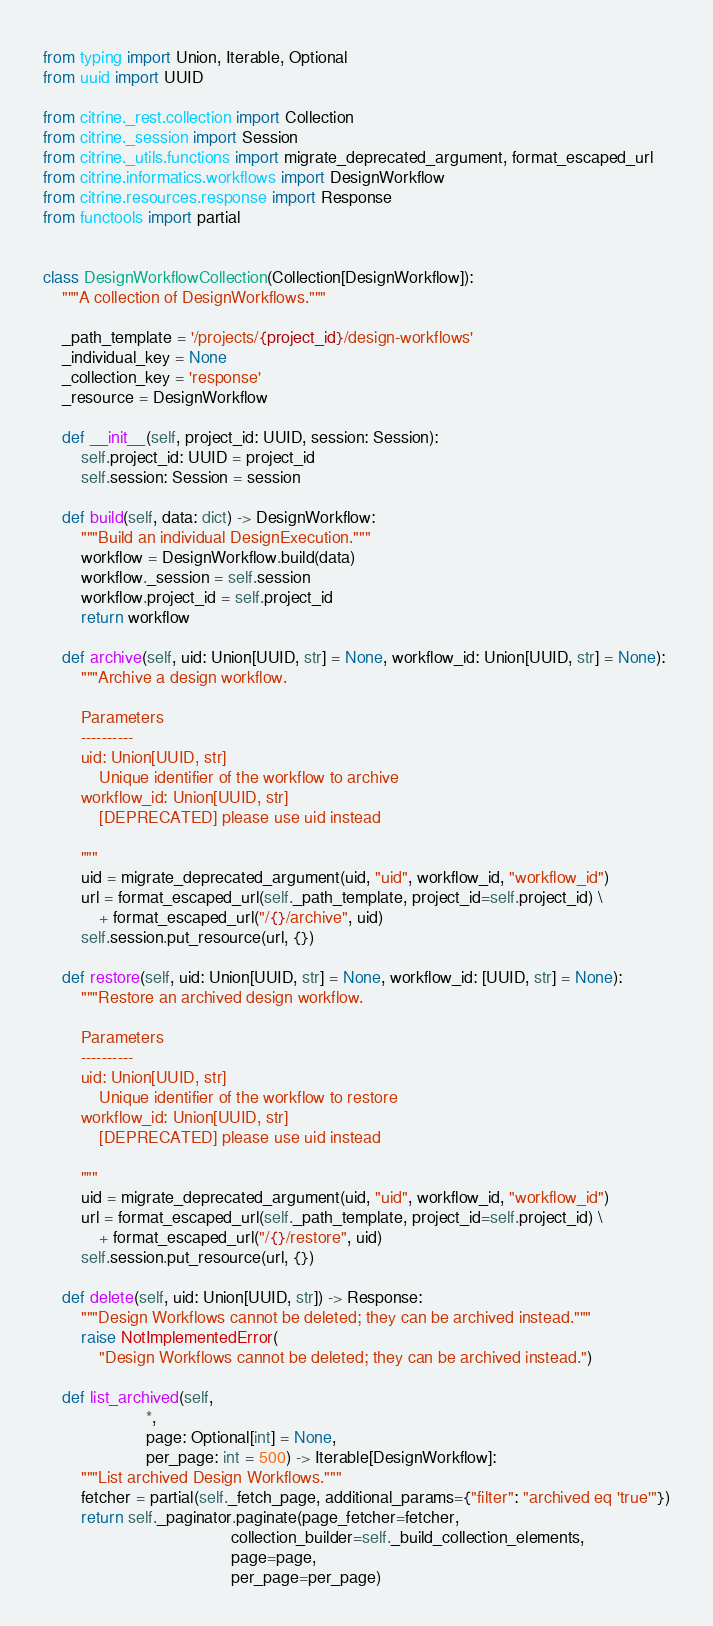Convert code to text. <code><loc_0><loc_0><loc_500><loc_500><_Python_>from typing import Union, Iterable, Optional
from uuid import UUID

from citrine._rest.collection import Collection
from citrine._session import Session
from citrine._utils.functions import migrate_deprecated_argument, format_escaped_url
from citrine.informatics.workflows import DesignWorkflow
from citrine.resources.response import Response
from functools import partial


class DesignWorkflowCollection(Collection[DesignWorkflow]):
    """A collection of DesignWorkflows."""

    _path_template = '/projects/{project_id}/design-workflows'
    _individual_key = None
    _collection_key = 'response'
    _resource = DesignWorkflow

    def __init__(self, project_id: UUID, session: Session):
        self.project_id: UUID = project_id
        self.session: Session = session

    def build(self, data: dict) -> DesignWorkflow:
        """Build an individual DesignExecution."""
        workflow = DesignWorkflow.build(data)
        workflow._session = self.session
        workflow.project_id = self.project_id
        return workflow

    def archive(self, uid: Union[UUID, str] = None, workflow_id: Union[UUID, str] = None):
        """Archive a design workflow.

        Parameters
        ----------
        uid: Union[UUID, str]
            Unique identifier of the workflow to archive
        workflow_id: Union[UUID, str]
            [DEPRECATED] please use uid instead

        """
        uid = migrate_deprecated_argument(uid, "uid", workflow_id, "workflow_id")
        url = format_escaped_url(self._path_template, project_id=self.project_id) \
            + format_escaped_url("/{}/archive", uid)
        self.session.put_resource(url, {})

    def restore(self, uid: Union[UUID, str] = None, workflow_id: [UUID, str] = None):
        """Restore an archived design workflow.

        Parameters
        ----------
        uid: Union[UUID, str]
            Unique identifier of the workflow to restore
        workflow_id: Union[UUID, str]
            [DEPRECATED] please use uid instead

        """
        uid = migrate_deprecated_argument(uid, "uid", workflow_id, "workflow_id")
        url = format_escaped_url(self._path_template, project_id=self.project_id) \
            + format_escaped_url("/{}/restore", uid)
        self.session.put_resource(url, {})

    def delete(self, uid: Union[UUID, str]) -> Response:
        """Design Workflows cannot be deleted; they can be archived instead."""
        raise NotImplementedError(
            "Design Workflows cannot be deleted; they can be archived instead.")

    def list_archived(self,
                      *,
                      page: Optional[int] = None,
                      per_page: int = 500) -> Iterable[DesignWorkflow]:
        """List archived Design Workflows."""
        fetcher = partial(self._fetch_page, additional_params={"filter": "archived eq 'true'"})
        return self._paginator.paginate(page_fetcher=fetcher,
                                        collection_builder=self._build_collection_elements,
                                        page=page,
                                        per_page=per_page)
</code> 